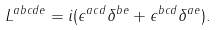<formula> <loc_0><loc_0><loc_500><loc_500>L ^ { a b c d e } = i ( \epsilon ^ { a c d } \delta ^ { b e } + \epsilon ^ { b c d } \delta ^ { a e } ) .</formula> 